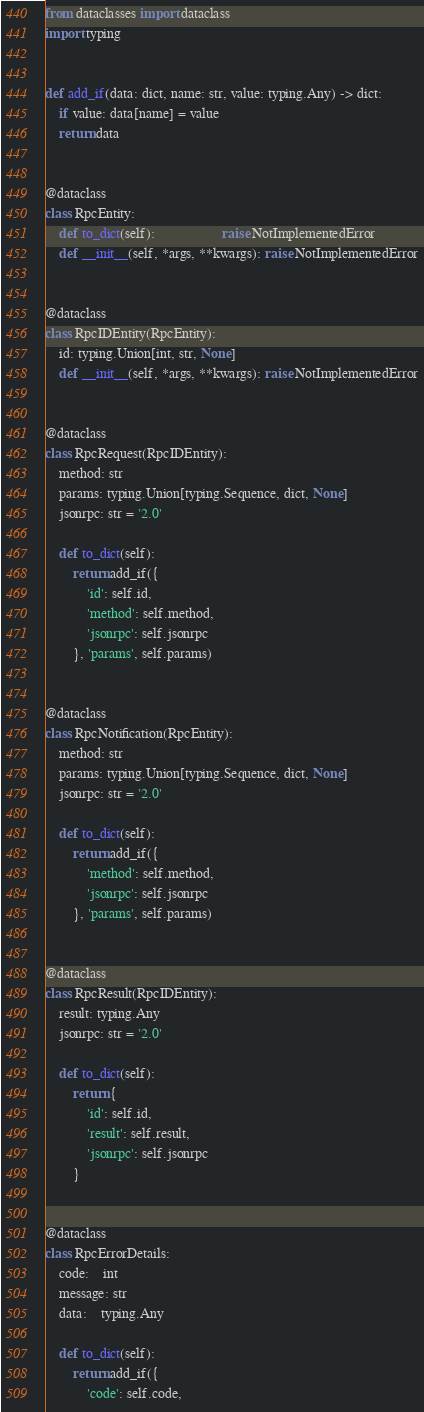<code> <loc_0><loc_0><loc_500><loc_500><_Python_>from dataclasses import dataclass
import typing


def add_if(data: dict, name: str, value: typing.Any) -> dict:
    if value: data[name] = value
    return data


@dataclass
class RpcEntity:
    def to_dict(self):                   raise NotImplementedError
    def __init__(self, *args, **kwargs): raise NotImplementedError


@dataclass
class RpcIDEntity(RpcEntity):
    id: typing.Union[int, str, None]
    def __init__(self, *args, **kwargs): raise NotImplementedError


@dataclass
class RpcRequest(RpcIDEntity):
    method: str
    params: typing.Union[typing.Sequence, dict, None]
    jsonrpc: str = '2.0'

    def to_dict(self):
        return add_if({
            'id': self.id,
            'method': self.method,
            'jsonrpc': self.jsonrpc
        }, 'params', self.params)


@dataclass
class RpcNotification(RpcEntity):
    method: str
    params: typing.Union[typing.Sequence, dict, None]
    jsonrpc: str = '2.0'

    def to_dict(self):
        return add_if({
            'method': self.method,
            'jsonrpc': self.jsonrpc
        }, 'params', self.params)


@dataclass
class RpcResult(RpcIDEntity):
    result: typing.Any
    jsonrpc: str = '2.0'

    def to_dict(self):
        return {
            'id': self.id,
            'result': self.result,
            'jsonrpc': self.jsonrpc
        }


@dataclass
class RpcErrorDetails:
    code:    int
    message: str
    data:    typing.Any

    def to_dict(self):
        return add_if({
            'code': self.code,</code> 